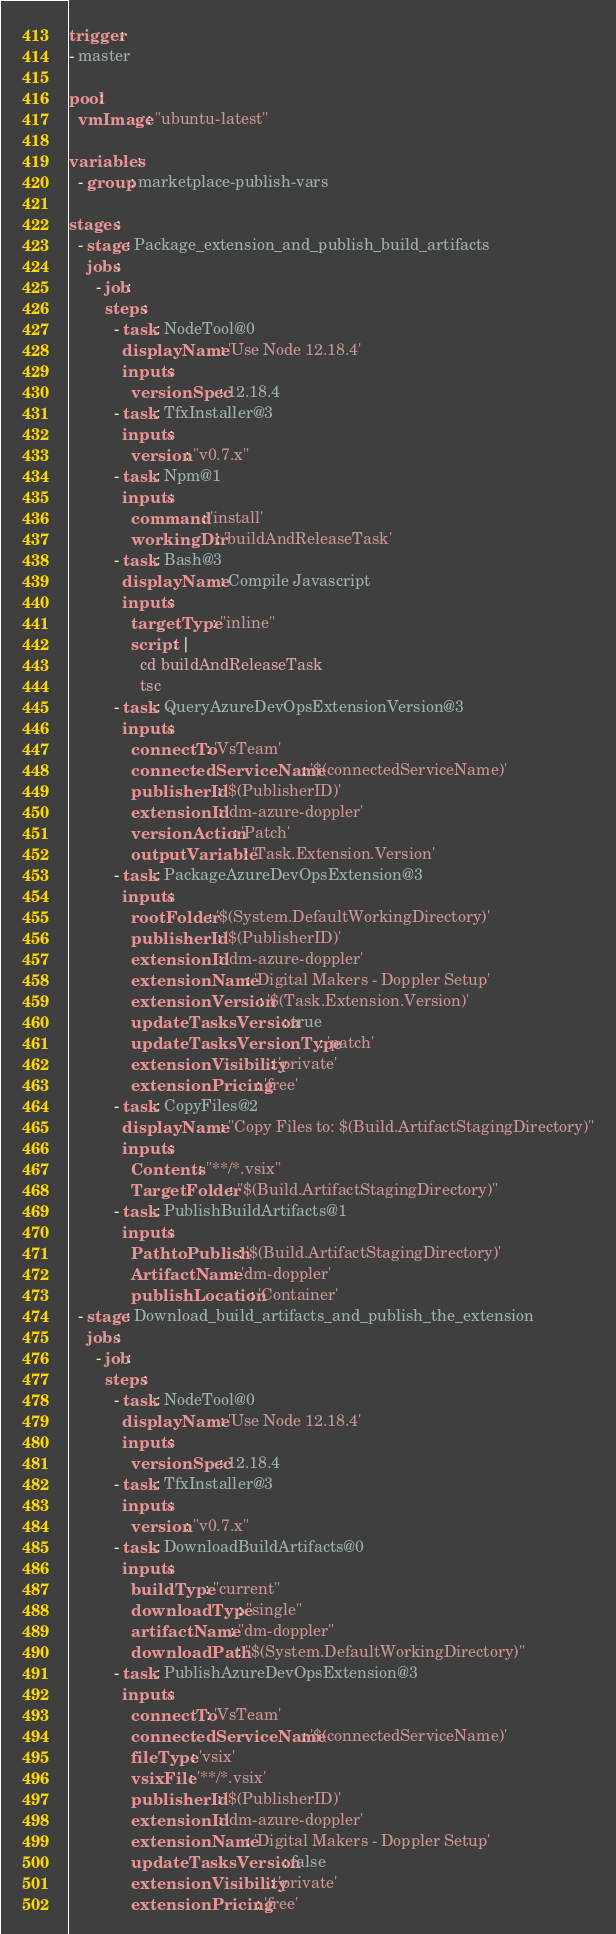<code> <loc_0><loc_0><loc_500><loc_500><_YAML_>trigger: 
- master

pool:
  vmImage: "ubuntu-latest"

variables:
  - group: marketplace-publish-vars

stages:
  - stage: Package_extension_and_publish_build_artifacts
    jobs:
      - job:
        steps:
          - task: NodeTool@0
            displayName: 'Use Node 12.18.4'
            inputs:
              versionSpec: 12.18.4
          - task: TfxInstaller@3
            inputs:
              version: "v0.7.x"
          - task: Npm@1
            inputs:
              command: 'install'
              workingDir: 'buildAndReleaseTask'
          - task: Bash@3
            displayName: Compile Javascript
            inputs:
              targetType: "inline"
              script: |
                cd buildAndReleaseTask
                tsc
          - task: QueryAzureDevOpsExtensionVersion@3
            inputs:
              connectTo: 'VsTeam'
              connectedServiceName: '$(connectedServiceName)'
              publisherId: '$(PublisherID)'
              extensionId: 'dm-azure-doppler'
              versionAction: 'Patch'
              outputVariable: 'Task.Extension.Version'
          - task: PackageAzureDevOpsExtension@3
            inputs:
              rootFolder: '$(System.DefaultWorkingDirectory)'
              publisherId: '$(PublisherID)'
              extensionId: 'dm-azure-doppler'
              extensionName: 'Digital Makers - Doppler Setup'
              extensionVersion: '$(Task.Extension.Version)'
              updateTasksVersion: true
              updateTasksVersionType: 'patch'
              extensionVisibility: 'private' 
              extensionPricing: 'free'
          - task: CopyFiles@2
            displayName: "Copy Files to: $(Build.ArtifactStagingDirectory)"
            inputs:
              Contents: "**/*.vsix"
              TargetFolder: "$(Build.ArtifactStagingDirectory)"
          - task: PublishBuildArtifacts@1
            inputs:
              PathtoPublish: '$(Build.ArtifactStagingDirectory)'
              ArtifactName: 'dm-doppler'
              publishLocation: 'Container'
  - stage: Download_build_artifacts_and_publish_the_extension
    jobs:
      - job:
        steps:
          - task: NodeTool@0
            displayName: 'Use Node 12.18.4'
            inputs:
              versionSpec: 12.18.4
          - task: TfxInstaller@3
            inputs:
              version: "v0.7.x"
          - task: DownloadBuildArtifacts@0
            inputs:
              buildType: "current"
              downloadType: "single"
              artifactName: "dm-doppler"
              downloadPath: "$(System.DefaultWorkingDirectory)"
          - task: PublishAzureDevOpsExtension@3
            inputs:
              connectTo: 'VsTeam'
              connectedServiceName: '$(connectedServiceName)' 
              fileType: 'vsix'
              vsixFile: '**/*.vsix'
              publisherId: '$(PublisherID)'
              extensionId: 'dm-azure-doppler'
              extensionName: 'Digital Makers - Doppler Setup'
              updateTasksVersion: false
              extensionVisibility: 'private' 
              extensionPricing: 'free'</code> 